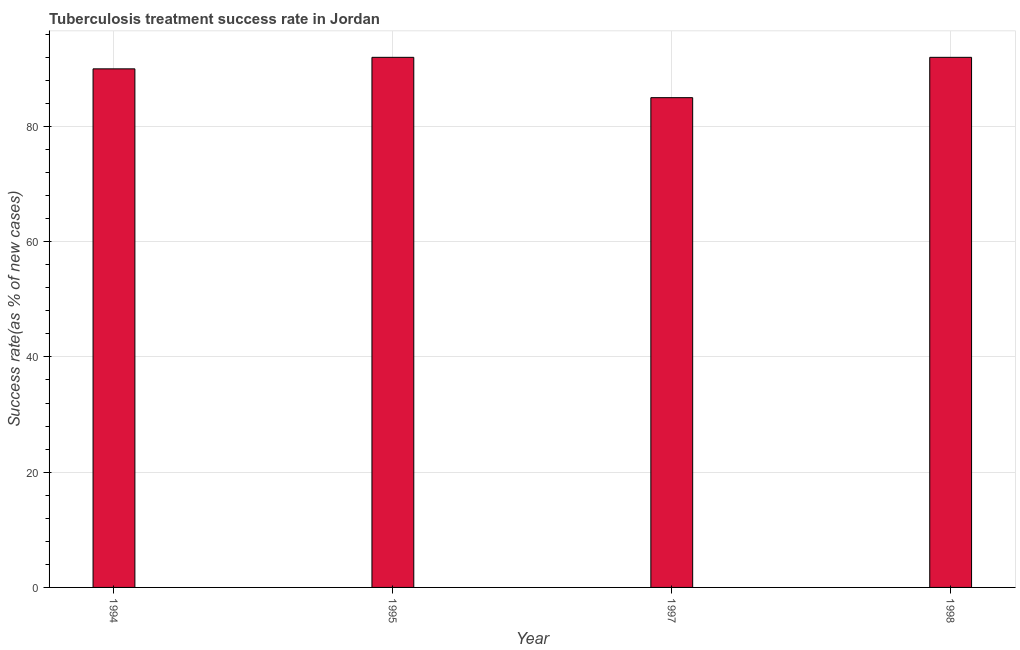Does the graph contain any zero values?
Your response must be concise. No. What is the title of the graph?
Offer a very short reply. Tuberculosis treatment success rate in Jordan. What is the label or title of the Y-axis?
Keep it short and to the point. Success rate(as % of new cases). What is the tuberculosis treatment success rate in 1997?
Your answer should be compact. 85. Across all years, what is the maximum tuberculosis treatment success rate?
Give a very brief answer. 92. Across all years, what is the minimum tuberculosis treatment success rate?
Offer a very short reply. 85. In which year was the tuberculosis treatment success rate maximum?
Provide a succinct answer. 1995. What is the sum of the tuberculosis treatment success rate?
Your answer should be compact. 359. What is the average tuberculosis treatment success rate per year?
Ensure brevity in your answer.  89. What is the median tuberculosis treatment success rate?
Provide a succinct answer. 91. What is the ratio of the tuberculosis treatment success rate in 1995 to that in 1998?
Make the answer very short. 1. Is the tuberculosis treatment success rate in 1995 less than that in 1998?
Ensure brevity in your answer.  No. Is the difference between the tuberculosis treatment success rate in 1994 and 1995 greater than the difference between any two years?
Your response must be concise. No. Are all the bars in the graph horizontal?
Provide a succinct answer. No. Are the values on the major ticks of Y-axis written in scientific E-notation?
Give a very brief answer. No. What is the Success rate(as % of new cases) in 1995?
Offer a terse response. 92. What is the Success rate(as % of new cases) of 1998?
Offer a terse response. 92. What is the difference between the Success rate(as % of new cases) in 1994 and 1995?
Your answer should be very brief. -2. What is the difference between the Success rate(as % of new cases) in 1995 and 1997?
Offer a terse response. 7. What is the difference between the Success rate(as % of new cases) in 1995 and 1998?
Ensure brevity in your answer.  0. What is the difference between the Success rate(as % of new cases) in 1997 and 1998?
Give a very brief answer. -7. What is the ratio of the Success rate(as % of new cases) in 1994 to that in 1995?
Ensure brevity in your answer.  0.98. What is the ratio of the Success rate(as % of new cases) in 1994 to that in 1997?
Give a very brief answer. 1.06. What is the ratio of the Success rate(as % of new cases) in 1994 to that in 1998?
Your answer should be compact. 0.98. What is the ratio of the Success rate(as % of new cases) in 1995 to that in 1997?
Your answer should be very brief. 1.08. What is the ratio of the Success rate(as % of new cases) in 1997 to that in 1998?
Your answer should be very brief. 0.92. 